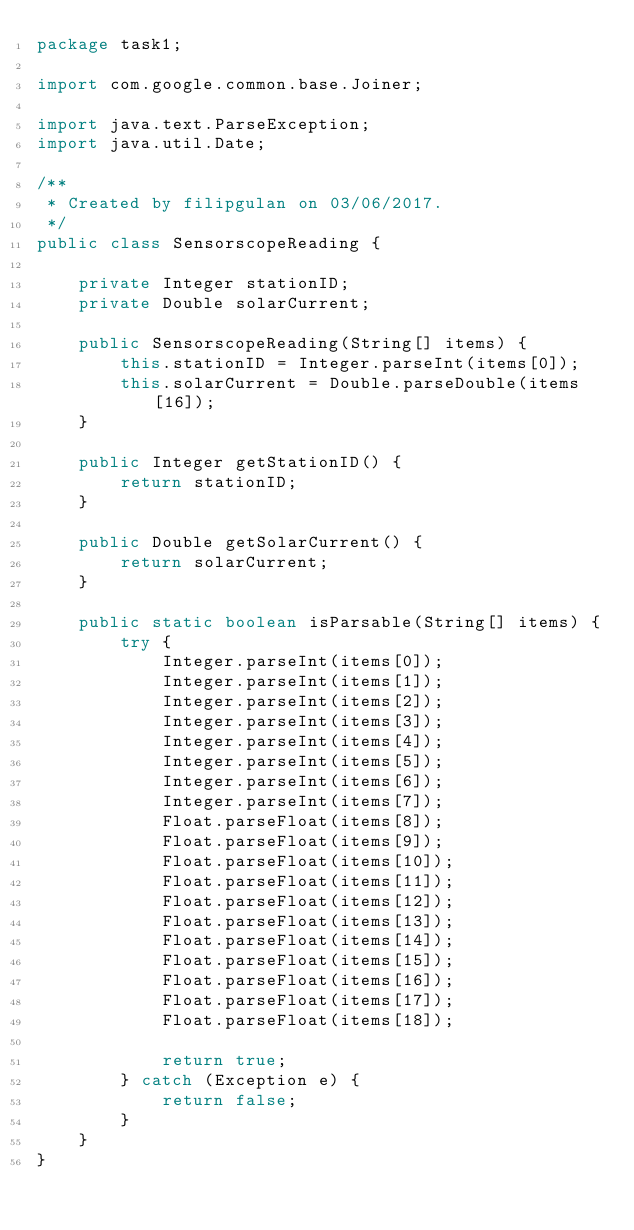<code> <loc_0><loc_0><loc_500><loc_500><_Java_>package task1;

import com.google.common.base.Joiner;

import java.text.ParseException;
import java.util.Date;

/**
 * Created by filipgulan on 03/06/2017.
 */
public class SensorscopeReading {

    private Integer stationID;
    private Double solarCurrent;

    public SensorscopeReading(String[] items) {
        this.stationID = Integer.parseInt(items[0]);
        this.solarCurrent = Double.parseDouble(items[16]);
    }

    public Integer getStationID() {
        return stationID;
    }

    public Double getSolarCurrent() {
        return solarCurrent;
    }

    public static boolean isParsable(String[] items) {
        try {
            Integer.parseInt(items[0]);
            Integer.parseInt(items[1]);
            Integer.parseInt(items[2]);
            Integer.parseInt(items[3]);
            Integer.parseInt(items[4]);
            Integer.parseInt(items[5]);
            Integer.parseInt(items[6]);
            Integer.parseInt(items[7]);
            Float.parseFloat(items[8]);
            Float.parseFloat(items[9]);
            Float.parseFloat(items[10]);
            Float.parseFloat(items[11]);
            Float.parseFloat(items[12]);
            Float.parseFloat(items[13]);
            Float.parseFloat(items[14]);
            Float.parseFloat(items[15]);
            Float.parseFloat(items[16]);
            Float.parseFloat(items[17]);
            Float.parseFloat(items[18]);

            return true;
        } catch (Exception e) {
            return false;
        }
    }
}
</code> 